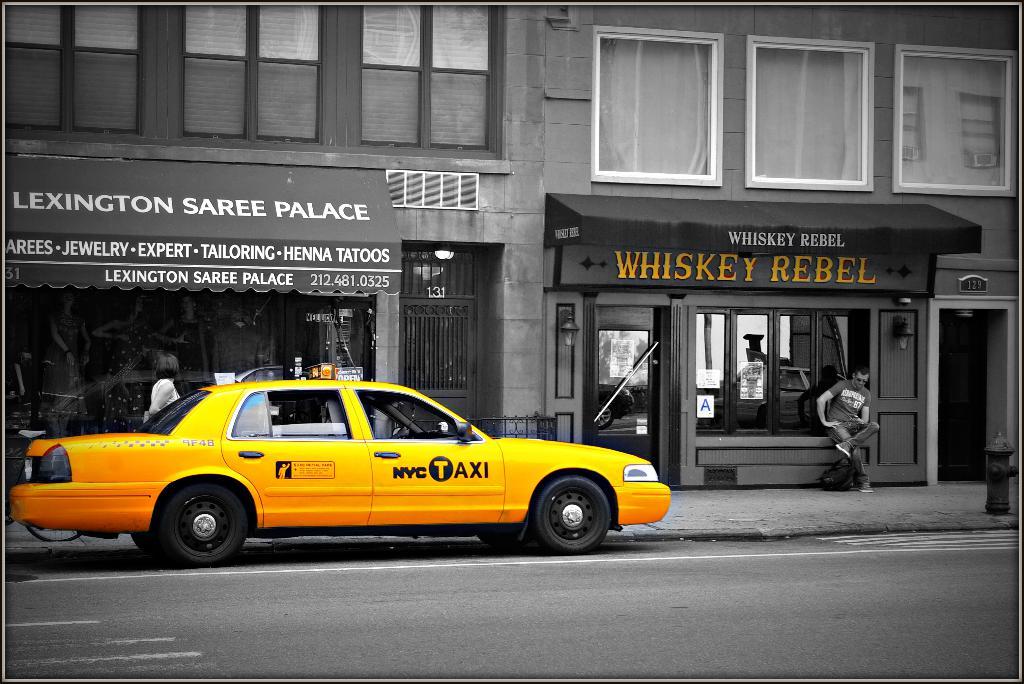What yellow car is parked out front?
Keep it short and to the point. Nyc taxi. What is that storefront called?
Your answer should be compact. Whiskey rebel. 